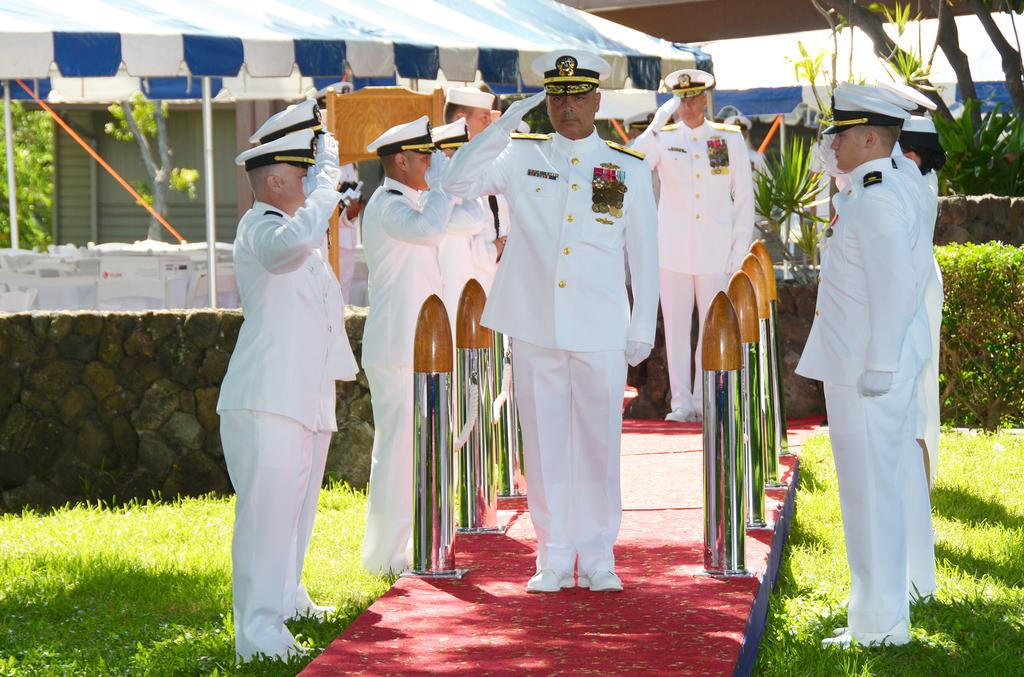What are the men in the image wearing? The men in the image are wearing white uniforms and white hats. What can be seen in the background of the image? There is grass, a wall, a tent, trees, and the sky visible in the background of the image. What type of paste is being used by the ghost in the image? There is no ghost present in the image, and therefore no such activity can be observed. 